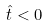Convert formula to latex. <formula><loc_0><loc_0><loc_500><loc_500>\hat { t } < 0</formula> 